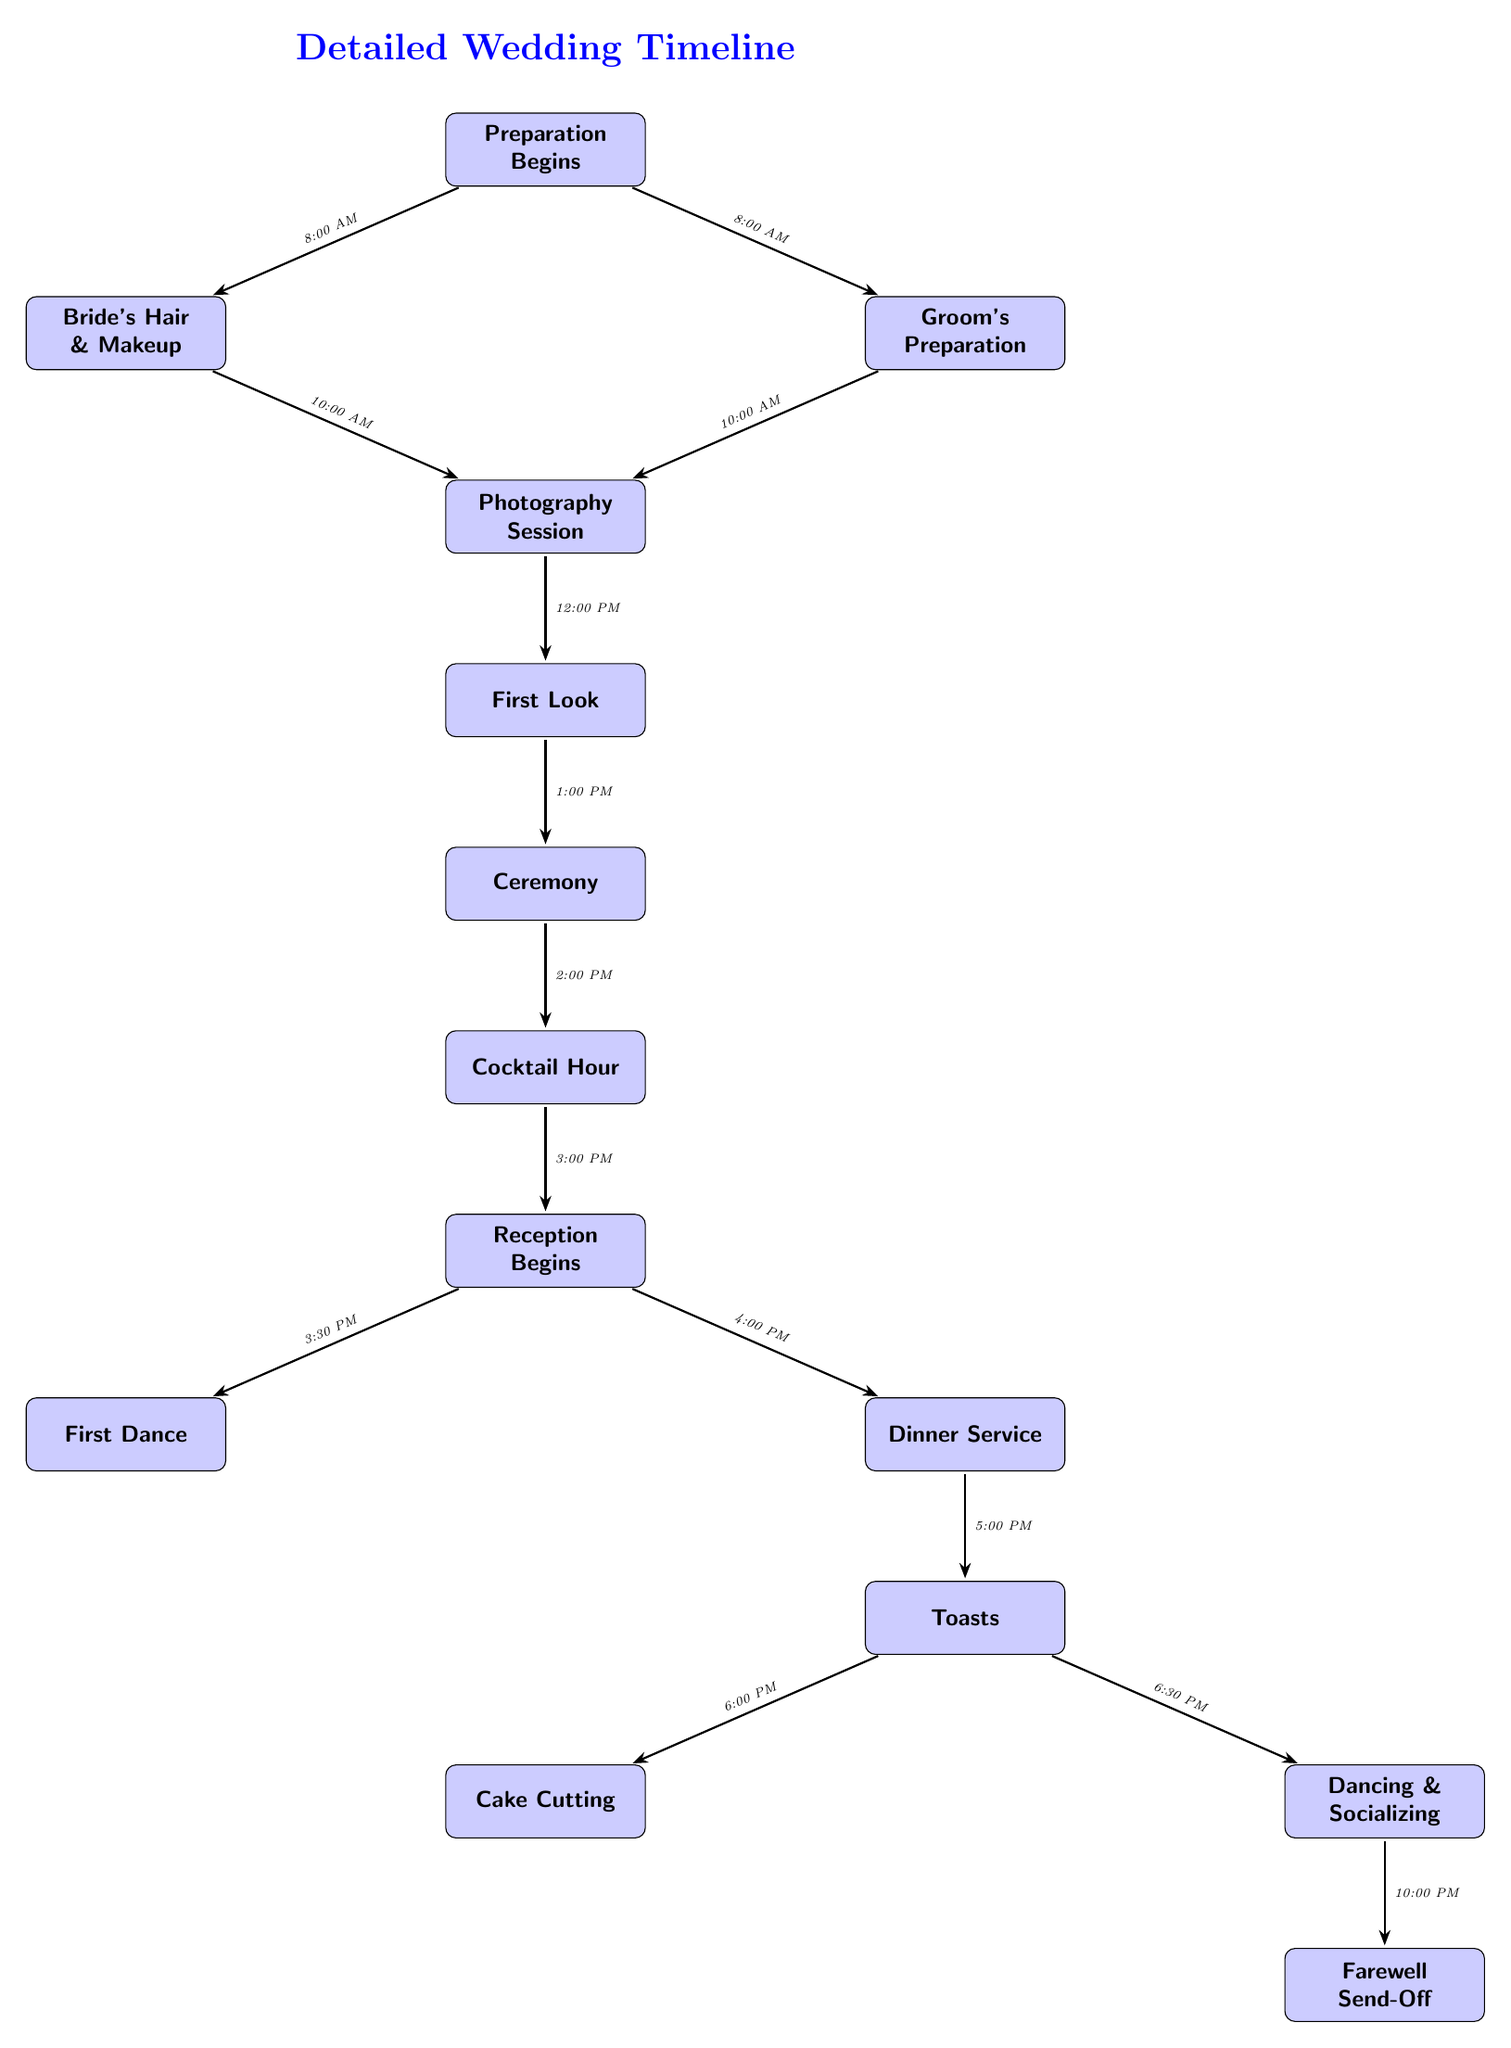What activity begins at 8:00 AM? The diagram indicates that both the Bride's Hair & Makeup and the Groom's Preparation begin at 8:00 AM.
Answer: Bride's Hair & Makeup, Groom's Preparation How many main events are listed in the timeline? By counting the events in the diagram, there are a total of 14 distinct activities outlined in the timeline.
Answer: 14 What time does the First Look occur? The arrows indicate that the First Look happens at 1:00 PM, which is directly after the Photography Session.
Answer: 1:00 PM What event follows the Cocktail Hour? According to the diagram, the Reception Begins occurs right after the Cocktail Hour, indicating the transition between these two events.
Answer: Reception Begins What is the final event in the timeline? The last activity shown in the timeline is the Farewell Send-Off, which concludes the sequence of events for the wedding day.
Answer: Farewell Send-Off How much time is allocated between the Ceremony and the Cocktail Hour? The timeline shows that the Ceremony ends at 2:00 PM and the Cocktail Hour begins at the same time, indicating there is no time allocated between them.
Answer: 0 minutes What is the first dance time? The First Dance activity starts at 3:30 PM, as indicated by the arrow pointing from the Reception Begins to this event.
Answer: 3:30 PM Which event is scheduled right before the Cake Cutting? The diagram indicates that the event preceding the Cake Cutting is the Toasts, which occurs at 6:00 PM, right before the Cake Cutting event.
Answer: Toasts What two events happen at 4:00 PM during the reception? At 4:00 PM, both Dinner Service and the beginning of the Reception are indicated in the diagram as events happening concurrently.
Answer: Dinner Service, Reception Begins 